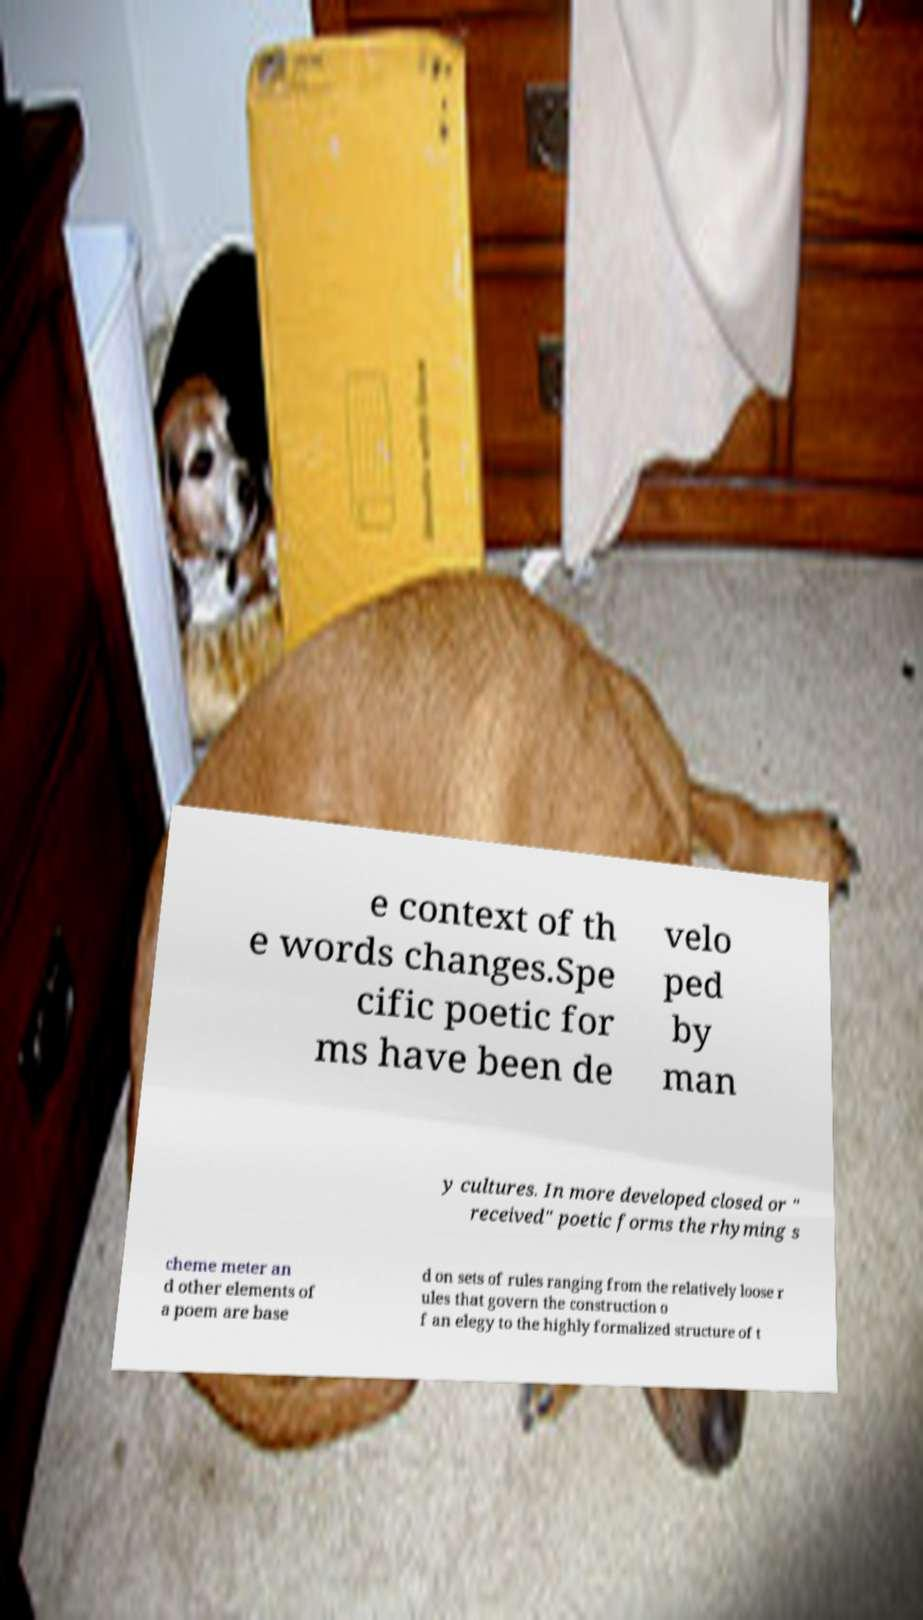Please identify and transcribe the text found in this image. e context of th e words changes.Spe cific poetic for ms have been de velo ped by man y cultures. In more developed closed or " received" poetic forms the rhyming s cheme meter an d other elements of a poem are base d on sets of rules ranging from the relatively loose r ules that govern the construction o f an elegy to the highly formalized structure of t 